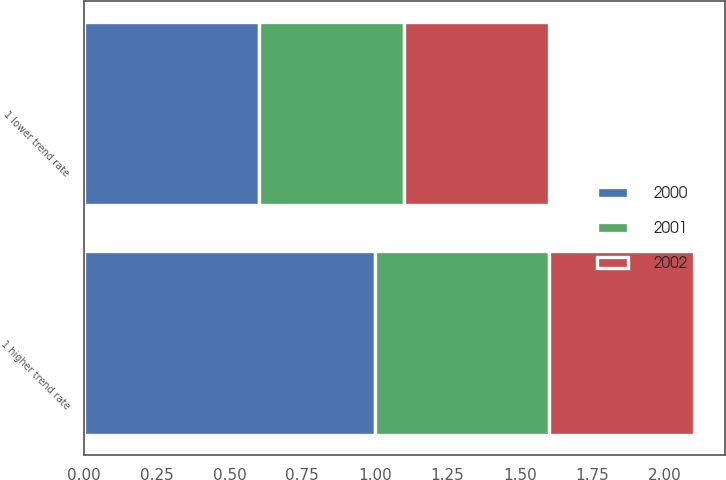Convert chart. <chart><loc_0><loc_0><loc_500><loc_500><stacked_bar_chart><ecel><fcel>1 higher trend rate<fcel>1 lower trend rate<nl><fcel>2002<fcel>0.5<fcel>0.5<nl><fcel>2001<fcel>0.6<fcel>0.5<nl><fcel>2000<fcel>1<fcel>0.6<nl></chart> 